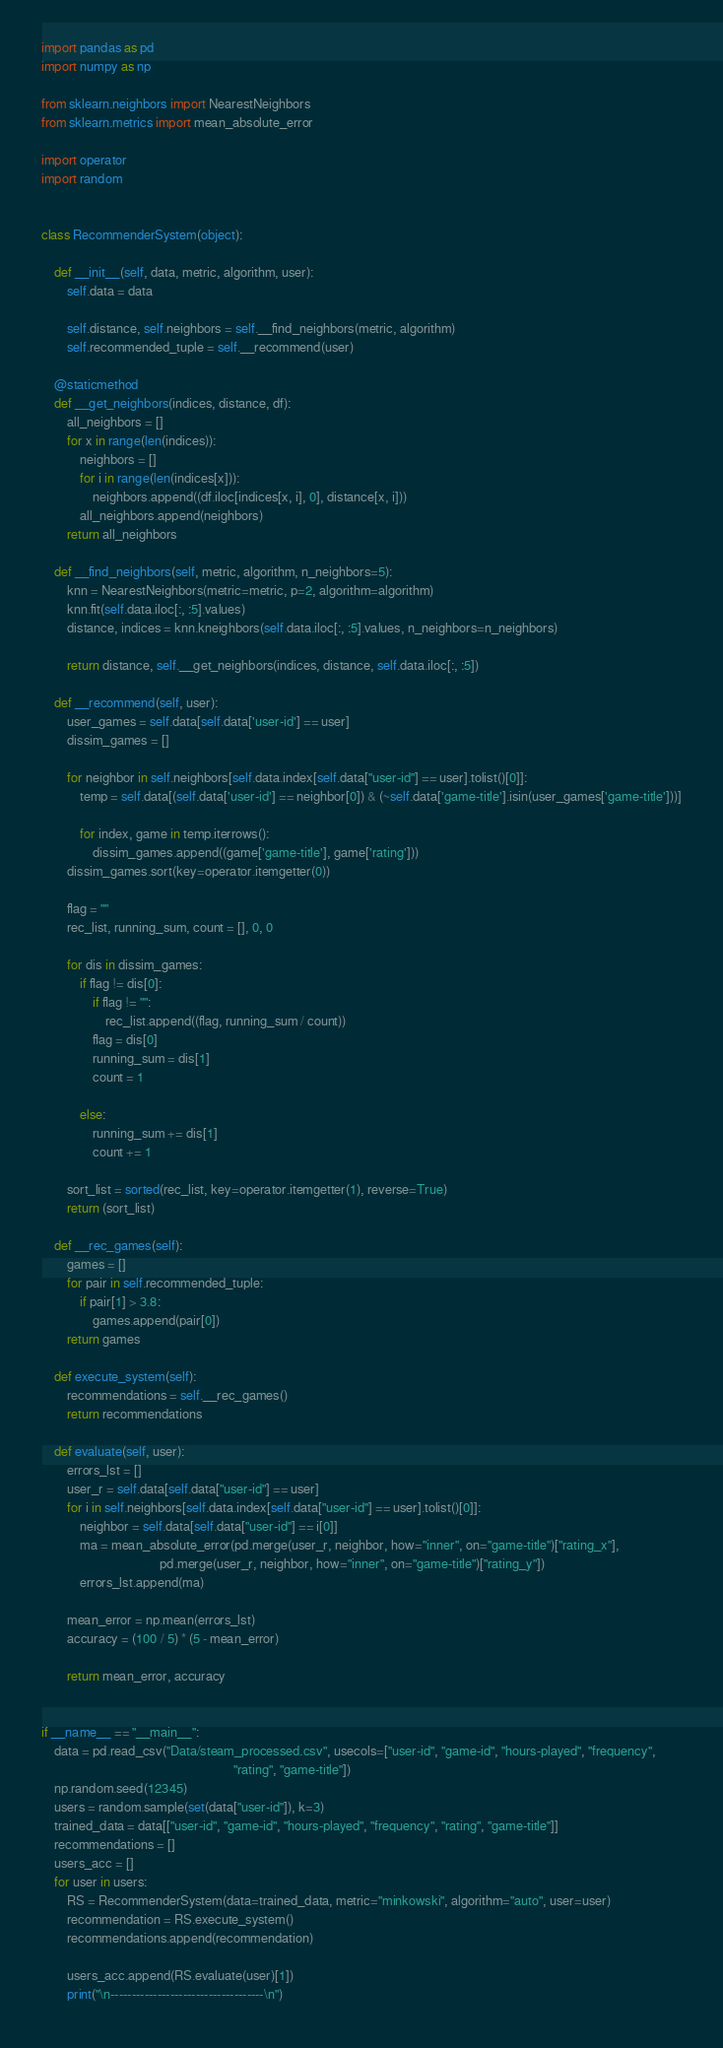Convert code to text. <code><loc_0><loc_0><loc_500><loc_500><_Python_>import pandas as pd
import numpy as np

from sklearn.neighbors import NearestNeighbors
from sklearn.metrics import mean_absolute_error

import operator
import random


class RecommenderSystem(object):

    def __init__(self, data, metric, algorithm, user):
        self.data = data

        self.distance, self.neighbors = self.__find_neighbors(metric, algorithm)
        self.recommended_tuple = self.__recommend(user)

    @staticmethod
    def __get_neighbors(indices, distance, df):
        all_neighbors = []
        for x in range(len(indices)):
            neighbors = []
            for i in range(len(indices[x])):
                neighbors.append((df.iloc[indices[x, i], 0], distance[x, i]))
            all_neighbors.append(neighbors)
        return all_neighbors

    def __find_neighbors(self, metric, algorithm, n_neighbors=5):
        knn = NearestNeighbors(metric=metric, p=2, algorithm=algorithm)
        knn.fit(self.data.iloc[:, :5].values)
        distance, indices = knn.kneighbors(self.data.iloc[:, :5].values, n_neighbors=n_neighbors)

        return distance, self.__get_neighbors(indices, distance, self.data.iloc[:, :5])

    def __recommend(self, user):
        user_games = self.data[self.data['user-id'] == user]
        dissim_games = []

        for neighbor in self.neighbors[self.data.index[self.data["user-id"] == user].tolist()[0]]:
            temp = self.data[(self.data['user-id'] == neighbor[0]) & (~self.data['game-title'].isin(user_games['game-title']))]

            for index, game in temp.iterrows():
                dissim_games.append((game['game-title'], game['rating']))
        dissim_games.sort(key=operator.itemgetter(0))

        flag = ""
        rec_list, running_sum, count = [], 0, 0

        for dis in dissim_games:
            if flag != dis[0]:
                if flag != "":
                    rec_list.append((flag, running_sum / count))
                flag = dis[0]
                running_sum = dis[1]
                count = 1

            else:
                running_sum += dis[1]
                count += 1

        sort_list = sorted(rec_list, key=operator.itemgetter(1), reverse=True)
        return (sort_list)

    def __rec_games(self):
        games = []
        for pair in self.recommended_tuple:
            if pair[1] > 3.8:
                games.append(pair[0])
        return games

    def execute_system(self):
        recommendations = self.__rec_games()
        return recommendations

    def evaluate(self, user):
        errors_lst = []
        user_r = self.data[self.data["user-id"] == user]
        for i in self.neighbors[self.data.index[self.data["user-id"] == user].tolist()[0]]:
            neighbor = self.data[self.data["user-id"] == i[0]]
            ma = mean_absolute_error(pd.merge(user_r, neighbor, how="inner", on="game-title")["rating_x"],
                                     pd.merge(user_r, neighbor, how="inner", on="game-title")["rating_y"])
            errors_lst.append(ma)

        mean_error = np.mean(errors_lst)
        accuracy = (100 / 5) * (5 - mean_error)

        return mean_error, accuracy


if __name__ == "__main__":
    data = pd.read_csv("Data/steam_processed.csv", usecols=["user-id", "game-id", "hours-played", "frequency",
                                                            "rating", "game-title"])
    np.random.seed(12345)
    users = random.sample(set(data["user-id"]), k=3)
    trained_data = data[["user-id", "game-id", "hours-played", "frequency", "rating", "game-title"]]
    recommendations = []
    users_acc = []
    for user in users:
        RS = RecommenderSystem(data=trained_data, metric="minkowski", algorithm="auto", user=user)
        recommendation = RS.execute_system()
        recommendations.append(recommendation)

        users_acc.append(RS.evaluate(user)[1])
        print("\n------------------------------------\n")</code> 